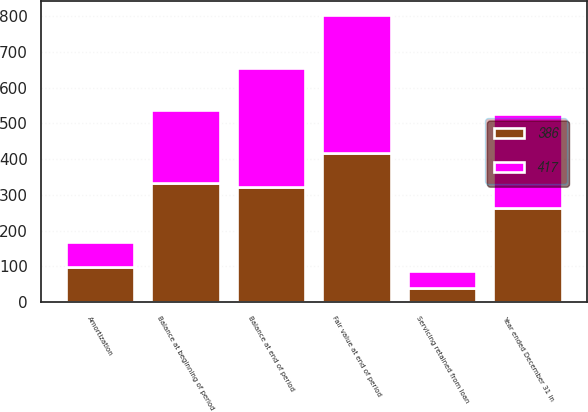Convert chart to OTSL. <chart><loc_0><loc_0><loc_500><loc_500><stacked_bar_chart><ecel><fcel>Year ended December 31 in<fcel>Balance at beginning of period<fcel>Servicing retained from loan<fcel>Amortization<fcel>Balance at end of period<fcel>Fair value at end of period<nl><fcel>386<fcel>263.5<fcel>332<fcel>38<fcel>98<fcel>323<fcel>417<nl><fcel>417<fcel>263.5<fcel>204<fcel>48<fcel>70<fcel>332<fcel>386<nl></chart> 